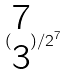Convert formula to latex. <formula><loc_0><loc_0><loc_500><loc_500>( \begin{matrix} 7 \\ 3 \end{matrix} ) / 2 ^ { 7 }</formula> 